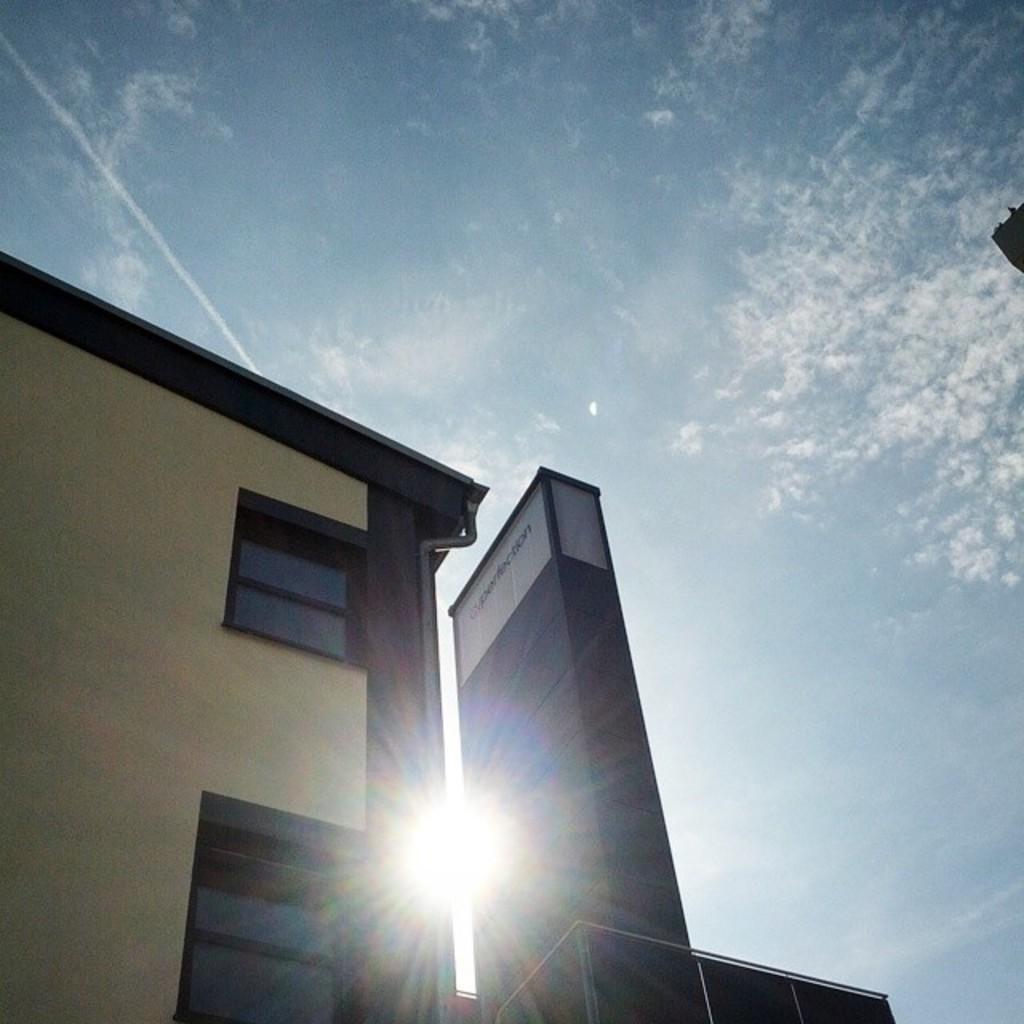In one or two sentences, can you explain what this image depicts? This picture is clicked outside. On the left we can see the building and the windows of the building and we can see a deck rail and a text on an object and we can see the sun light. In the background we can see the sky. 